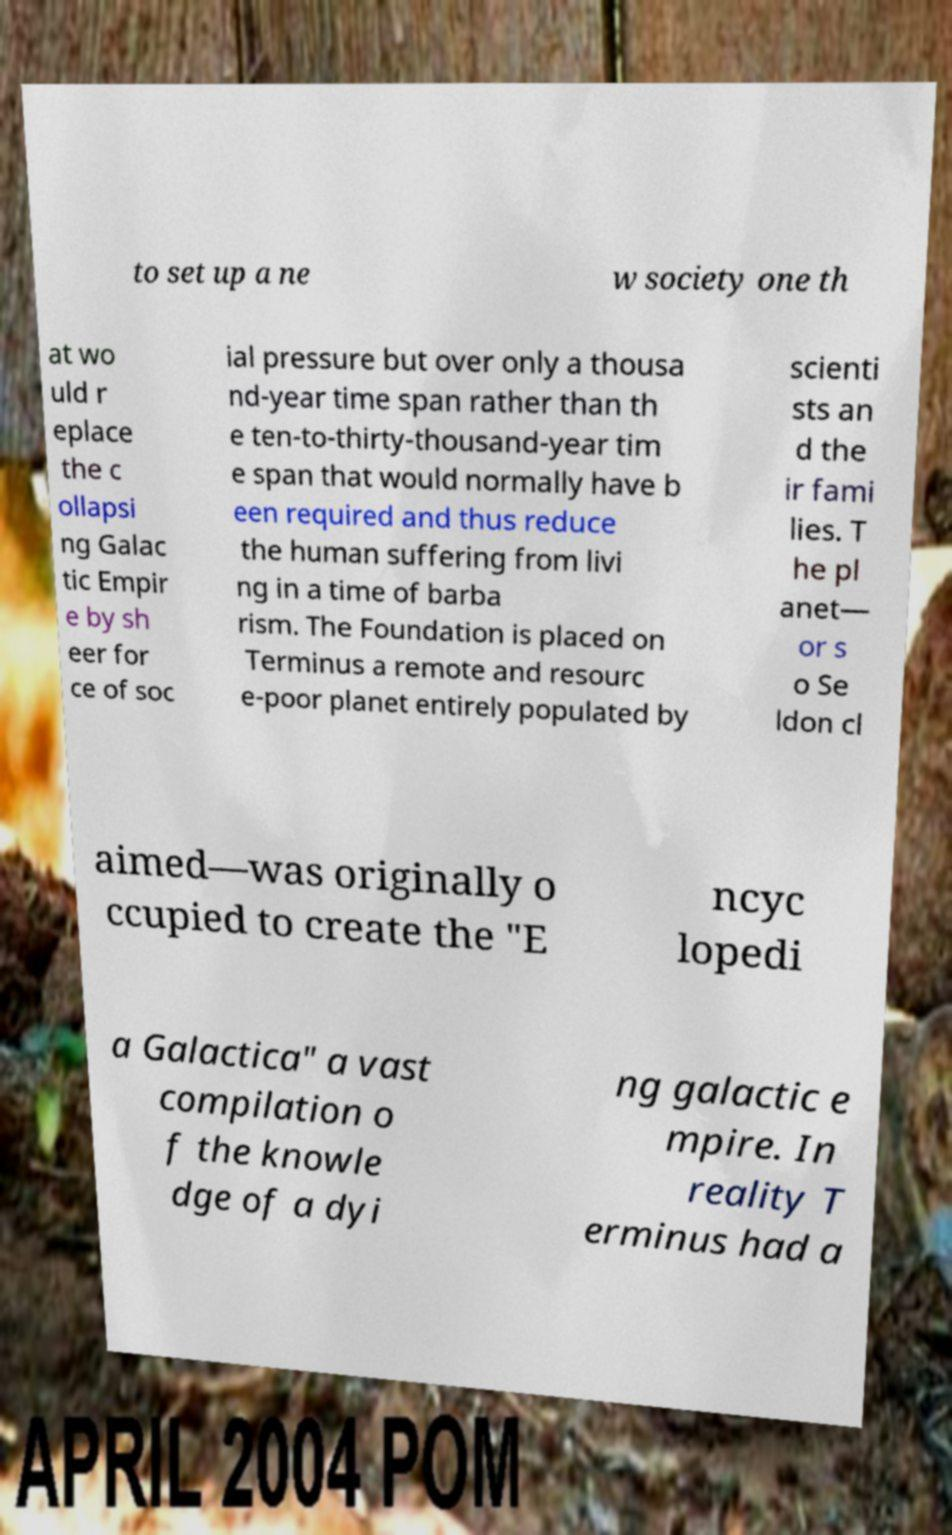Could you assist in decoding the text presented in this image and type it out clearly? to set up a ne w society one th at wo uld r eplace the c ollapsi ng Galac tic Empir e by sh eer for ce of soc ial pressure but over only a thousa nd-year time span rather than th e ten-to-thirty-thousand-year tim e span that would normally have b een required and thus reduce the human suffering from livi ng in a time of barba rism. The Foundation is placed on Terminus a remote and resourc e-poor planet entirely populated by scienti sts an d the ir fami lies. T he pl anet— or s o Se ldon cl aimed—was originally o ccupied to create the "E ncyc lopedi a Galactica" a vast compilation o f the knowle dge of a dyi ng galactic e mpire. In reality T erminus had a 